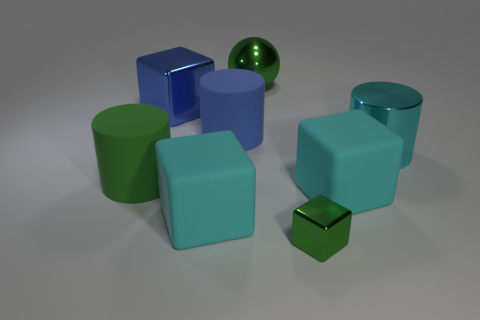How many things are either cylinders that are on the left side of the small green thing or matte objects that are in front of the large cyan cylinder? There are a total of four objects that meet this criteria. On the left side of the small green sphere, there is one green cylinder. In front of the large cyan cylinder, there are three matte objects: two cubes and one small cylinder, which are discernible by their non-reflective surfaces. 